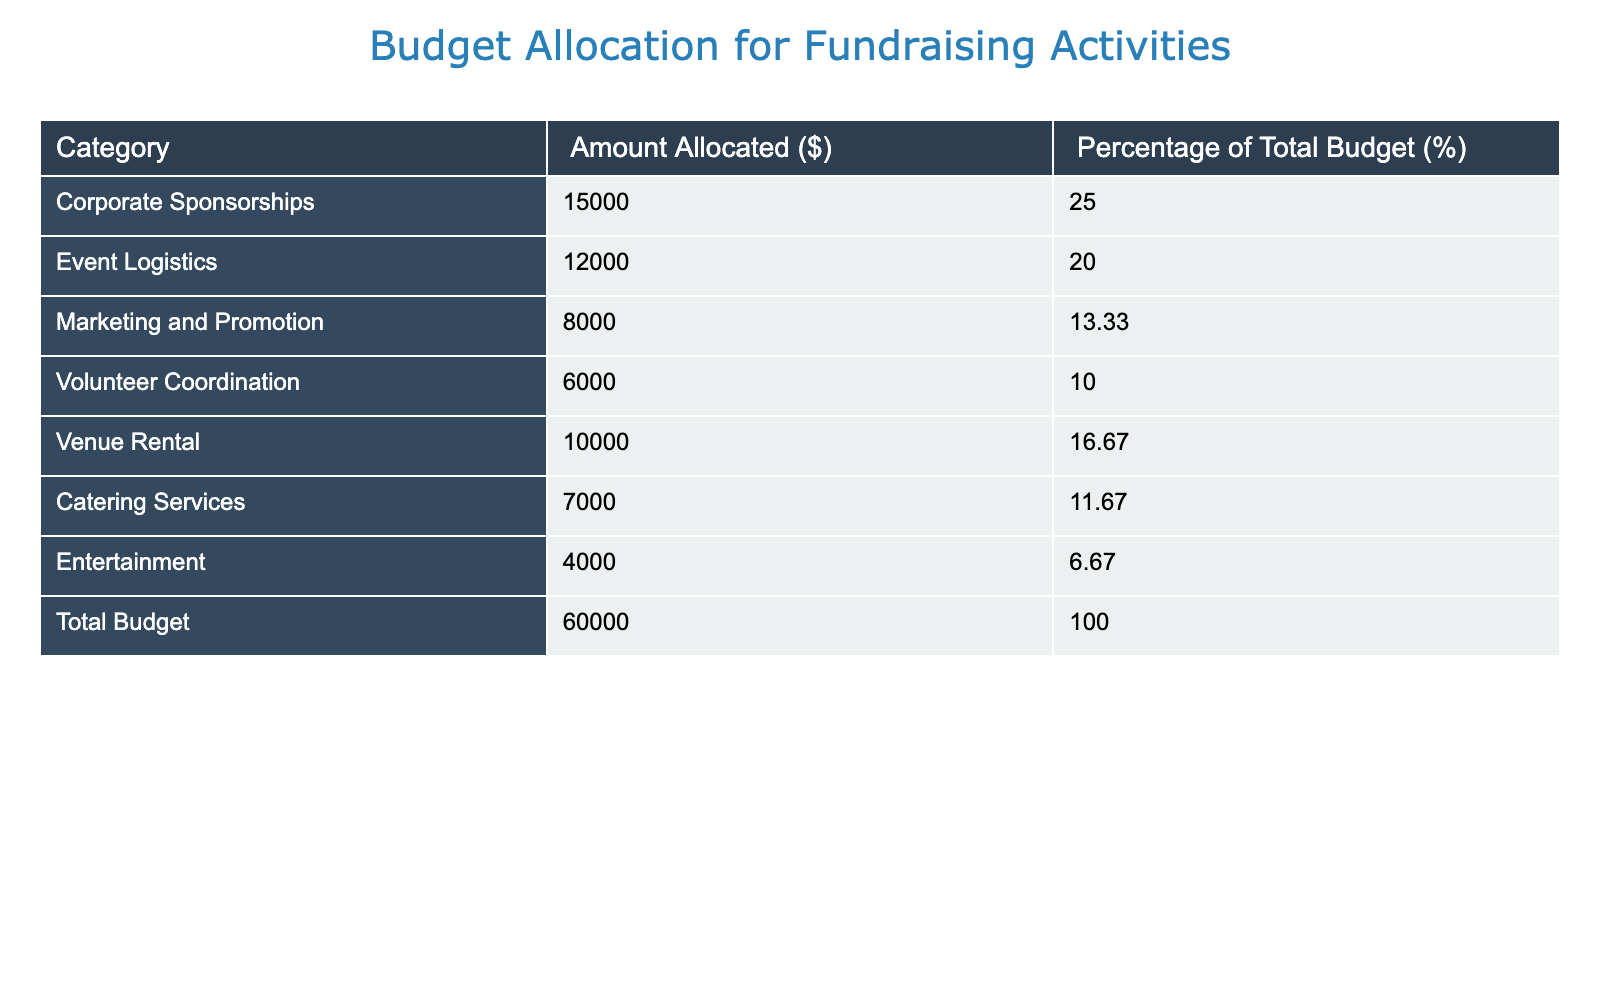What is the amount allocated for Corporate Sponsorships? The table directly lists the amount allocated for Corporate Sponsorships under the "Amount Allocated ($)" column, which is $15,000.
Answer: $15,000 What percentage of the total budget is allocated to Event Logistics? The table presents the percentage allocated to Event Logistics in the "Percentage of Total Budget (%)" column, which is 20%.
Answer: 20% How much more is allocated to Venue Rental compared to Volunteer Coordination? Venue Rental is allocated $10,000 and Volunteer Coordination is allocated $6,000. The difference is calculated by subtracting the latter from the former: $10,000 - $6,000 = $4,000.
Answer: $4,000 What is the total amount allocated for Catering Services and Entertainment combined? Catering Services is allocated $7,000 and Entertainment is allocated $4,000. To find the total allocated, we sum these amounts: $7,000 + $4,000 = $11,000.
Answer: $11,000 Is the amount allocated for Marketing and Promotion less than 15% of the total budget? Marketing and Promotion is allocated $8,000. To determine if this is less than 15% of the total budget ($60,000), we calculate 15% of $60,000 which is $9,000. Since $8,000 is less than $9,000, the statement is true.
Answer: Yes What is the average allocation percentage of the three categories: Catering Services, Volunteer Coordination, and Event Logistics? Catering Services is 11.67%, Volunteer Coordination is 10%, and Event Logistics is 20%. First, we sum these percentages: 11.67 + 10 + 20 = 41.67%. Next, we divide by the number of categories (3): 41.67% / 3 = approximately 13.89%.
Answer: 13.89% How does the allocation for Corporate Sponsorships compare with the combined total of Catering Services and Entertainment? Corporate Sponsorships are allocated $15,000. The combined total of Catering Services ($7,000) and Entertainment ($4,000) is $11,000. By comparing, we find that $15,000 is greater than $11,000.
Answer: Greater What is the total budget minus the allocation for the smallest category, which is Entertainment? The total budget is $60,000 and the smallest category, Entertainment, is allocated $4,000. We subtract the smallest category from the total budget: $60,000 - $4,000 = $56,000.
Answer: $56,000 